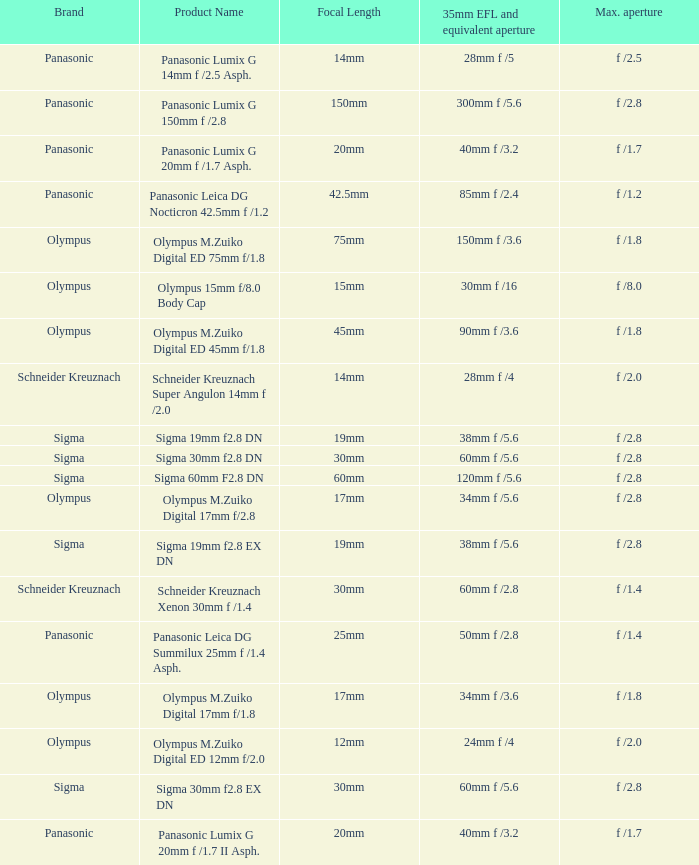What is the 35mm EFL and the equivalent aperture of the lens(es) with a maximum aperture of f /2.5? 28mm f /5. 